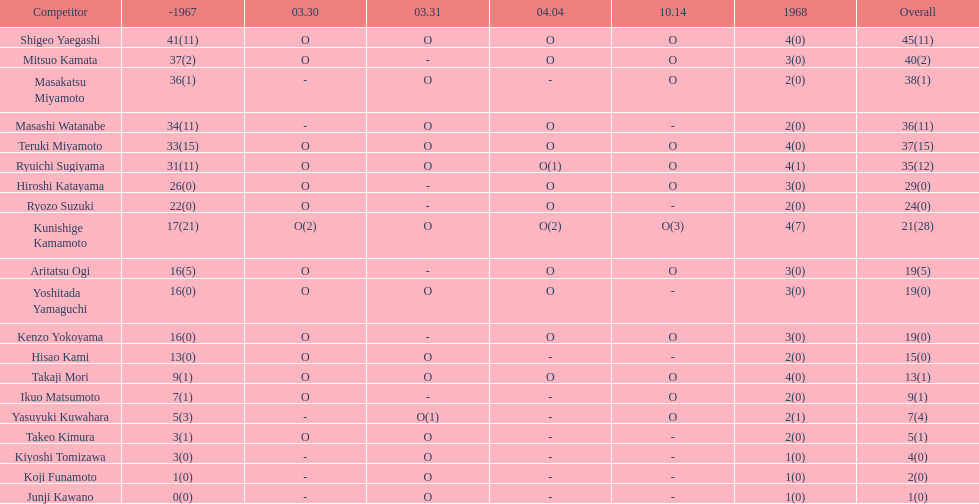How many more total appearances did shigeo yaegashi have than mitsuo kamata? 5. 